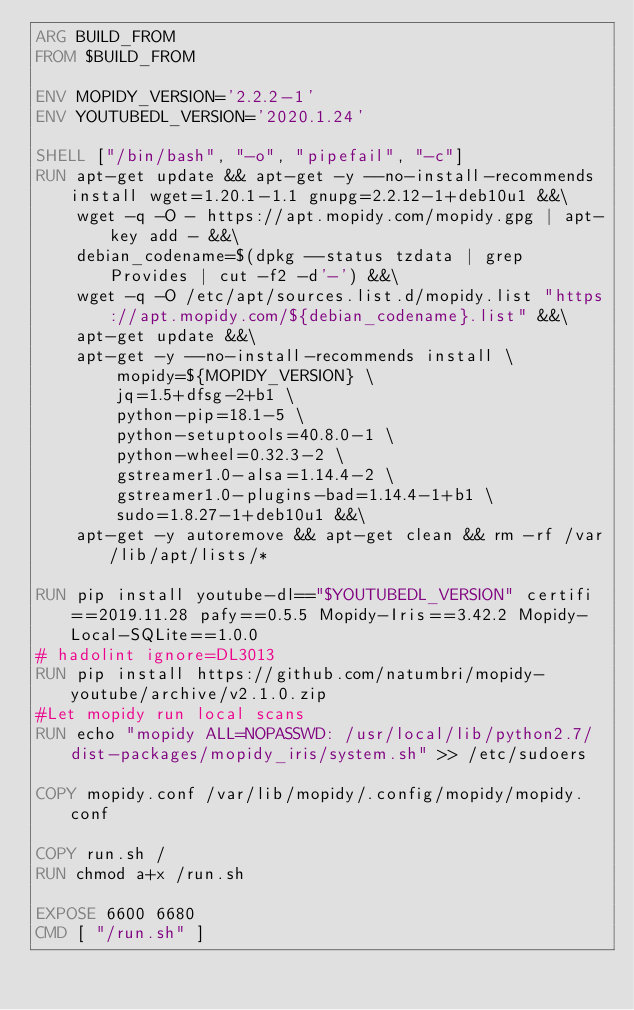<code> <loc_0><loc_0><loc_500><loc_500><_Dockerfile_>ARG BUILD_FROM
FROM $BUILD_FROM

ENV MOPIDY_VERSION='2.2.2-1'
ENV YOUTUBEDL_VERSION='2020.1.24'

SHELL ["/bin/bash", "-o", "pipefail", "-c"]
RUN apt-get update && apt-get -y --no-install-recommends install wget=1.20.1-1.1 gnupg=2.2.12-1+deb10u1 &&\
    wget -q -O - https://apt.mopidy.com/mopidy.gpg | apt-key add - &&\
    debian_codename=$(dpkg --status tzdata | grep Provides | cut -f2 -d'-') &&\
    wget -q -O /etc/apt/sources.list.d/mopidy.list "https://apt.mopidy.com/${debian_codename}.list" &&\
    apt-get update &&\
    apt-get -y --no-install-recommends install \
        mopidy=${MOPIDY_VERSION} \
        jq=1.5+dfsg-2+b1 \
        python-pip=18.1-5 \
        python-setuptools=40.8.0-1 \
        python-wheel=0.32.3-2 \
        gstreamer1.0-alsa=1.14.4-2 \
        gstreamer1.0-plugins-bad=1.14.4-1+b1 \
        sudo=1.8.27-1+deb10u1 &&\
    apt-get -y autoremove && apt-get clean && rm -rf /var/lib/apt/lists/*

RUN pip install youtube-dl=="$YOUTUBEDL_VERSION" certifi==2019.11.28 pafy==0.5.5 Mopidy-Iris==3.42.2 Mopidy-Local-SQLite==1.0.0 
# hadolint ignore=DL3013
RUN pip install https://github.com/natumbri/mopidy-youtube/archive/v2.1.0.zip
#Let mopidy run local scans
RUN echo "mopidy ALL=NOPASSWD: /usr/local/lib/python2.7/dist-packages/mopidy_iris/system.sh" >> /etc/sudoers

COPY mopidy.conf /var/lib/mopidy/.config/mopidy/mopidy.conf

COPY run.sh /
RUN chmod a+x /run.sh

EXPOSE 6600 6680
CMD [ "/run.sh" ]
</code> 